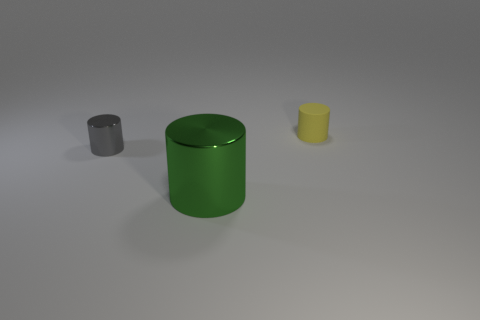Add 1 small cyan rubber objects. How many objects exist? 4 Add 2 matte cylinders. How many matte cylinders are left? 3 Add 3 gray cylinders. How many gray cylinders exist? 4 Subtract 0 brown balls. How many objects are left? 3 Subtract all brown metallic cubes. Subtract all tiny gray cylinders. How many objects are left? 2 